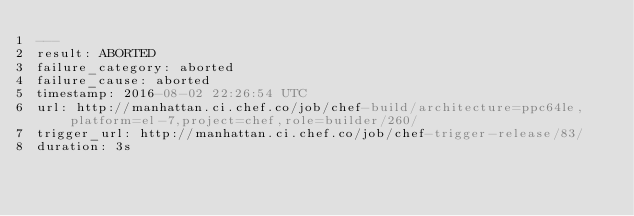<code> <loc_0><loc_0><loc_500><loc_500><_YAML_>---
result: ABORTED
failure_category: aborted
failure_cause: aborted
timestamp: 2016-08-02 22:26:54 UTC
url: http://manhattan.ci.chef.co/job/chef-build/architecture=ppc64le,platform=el-7,project=chef,role=builder/260/
trigger_url: http://manhattan.ci.chef.co/job/chef-trigger-release/83/
duration: 3s
</code> 